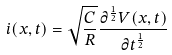<formula> <loc_0><loc_0><loc_500><loc_500>i ( x , t ) = \sqrt { \frac { C } { R } } \frac { { \partial } ^ { \frac { 1 } { 2 } } V ( x , t ) } { \partial t ^ { \frac { 1 } { 2 } } }</formula> 